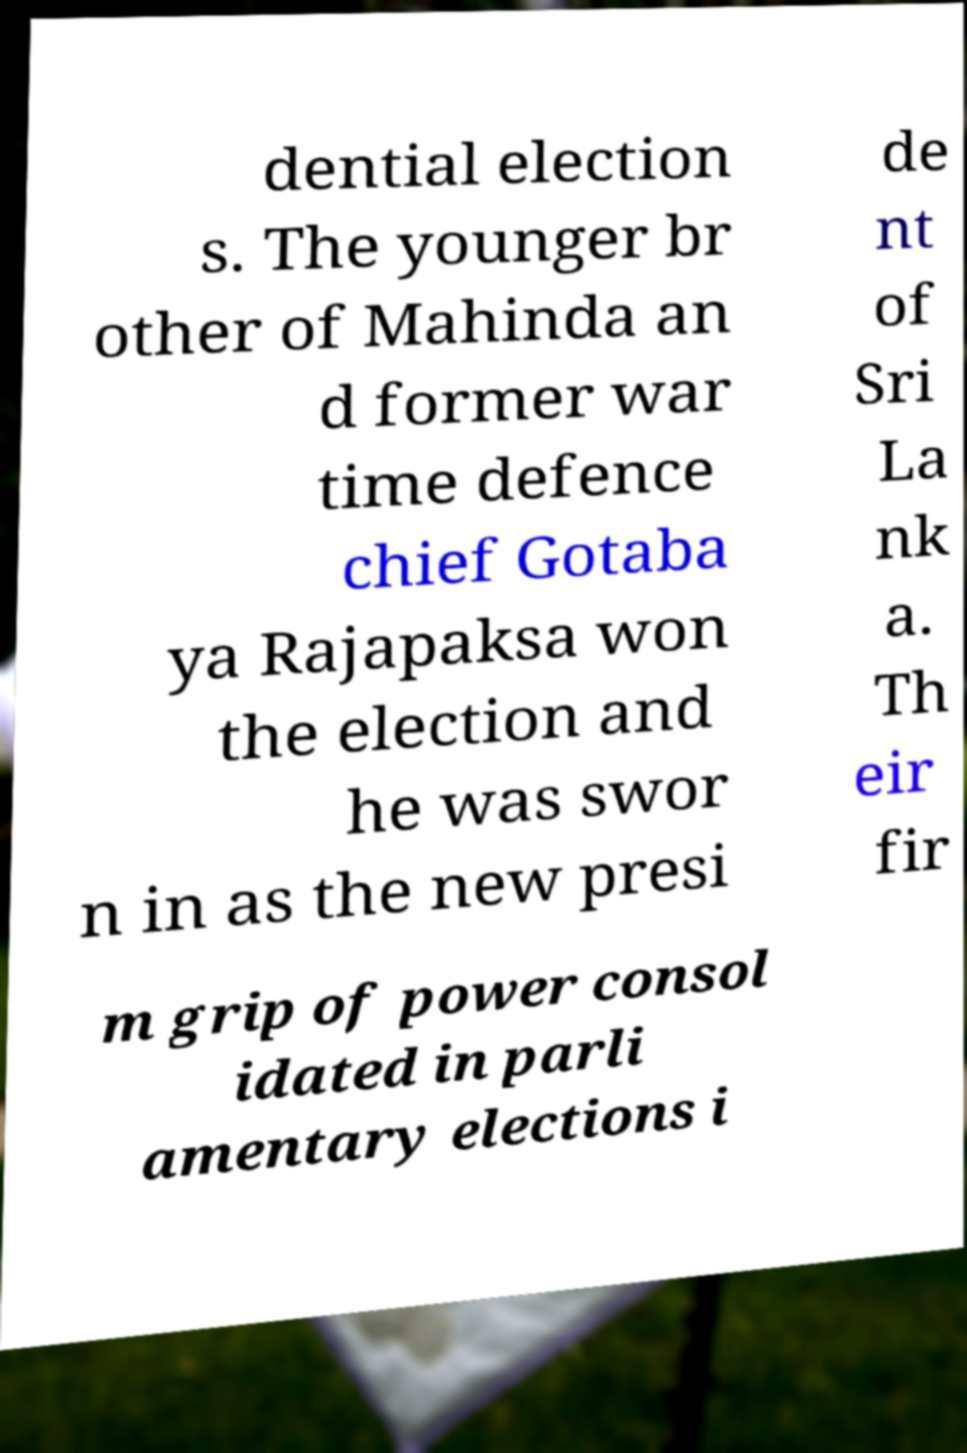Can you read and provide the text displayed in the image?This photo seems to have some interesting text. Can you extract and type it out for me? dential election s. The younger br other of Mahinda an d former war time defence chief Gotaba ya Rajapaksa won the election and he was swor n in as the new presi de nt of Sri La nk a. Th eir fir m grip of power consol idated in parli amentary elections i 